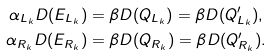<formula> <loc_0><loc_0><loc_500><loc_500>\alpha _ { L _ { k } } D ( E _ { L _ { k } } ) & = \beta D ( Q _ { L _ { k } } ) = \beta D ( Q ^ { \prime } _ { L _ { k } } ) , \\ \alpha _ { R _ { k } } D ( E _ { R _ { k } } ) & = \beta D ( Q _ { R _ { k } } ) = \beta D ( Q ^ { \prime } _ { R _ { k } } ) .</formula> 